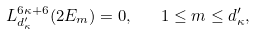<formula> <loc_0><loc_0><loc_500><loc_500>L _ { d _ { \kappa } ^ { \prime } } ^ { 6 \kappa + 6 } ( 2 E _ { m } ) = 0 , \quad 1 \leq m \leq d _ { \kappa } ^ { \prime } ,</formula> 